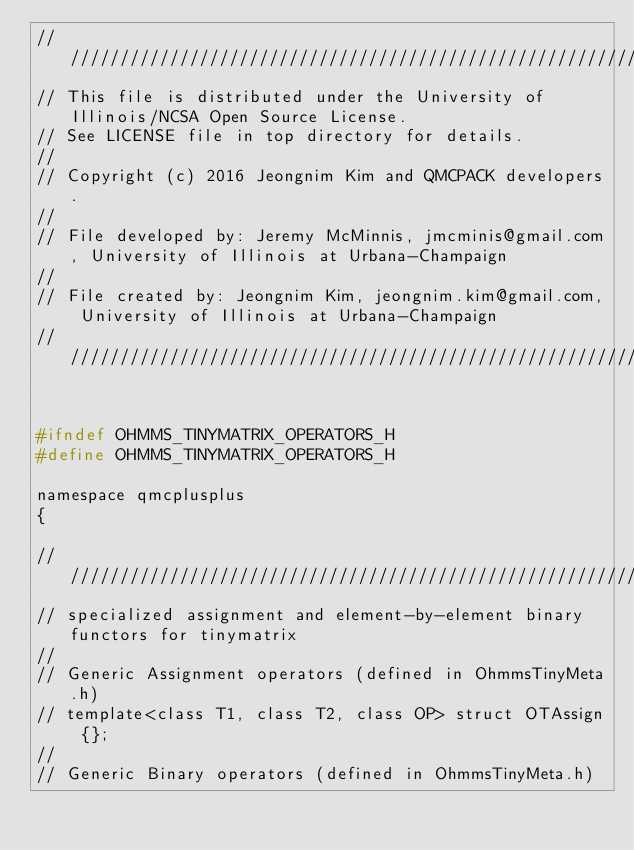<code> <loc_0><loc_0><loc_500><loc_500><_C_>//////////////////////////////////////////////////////////////////////////////////////
// This file is distributed under the University of Illinois/NCSA Open Source License.
// See LICENSE file in top directory for details.
//
// Copyright (c) 2016 Jeongnim Kim and QMCPACK developers.
//
// File developed by: Jeremy McMinnis, jmcminis@gmail.com, University of Illinois at Urbana-Champaign   
//
// File created by: Jeongnim Kim, jeongnim.kim@gmail.com, University of Illinois at Urbana-Champaign 
//////////////////////////////////////////////////////////////////////////////////////


#ifndef OHMMS_TINYMATRIX_OPERATORS_H
#define OHMMS_TINYMATRIX_OPERATORS_H

namespace qmcplusplus
{

///////////////////////////////////////////////////////////////////////
// specialized assignment and element-by-element binary functors for tinymatrix
//
// Generic Assignment operators (defined in OhmmsTinyMeta.h)
// template<class T1, class T2, class OP> struct OTAssign {};
//
// Generic Binary operators (defined in OhmmsTinyMeta.h)</code> 